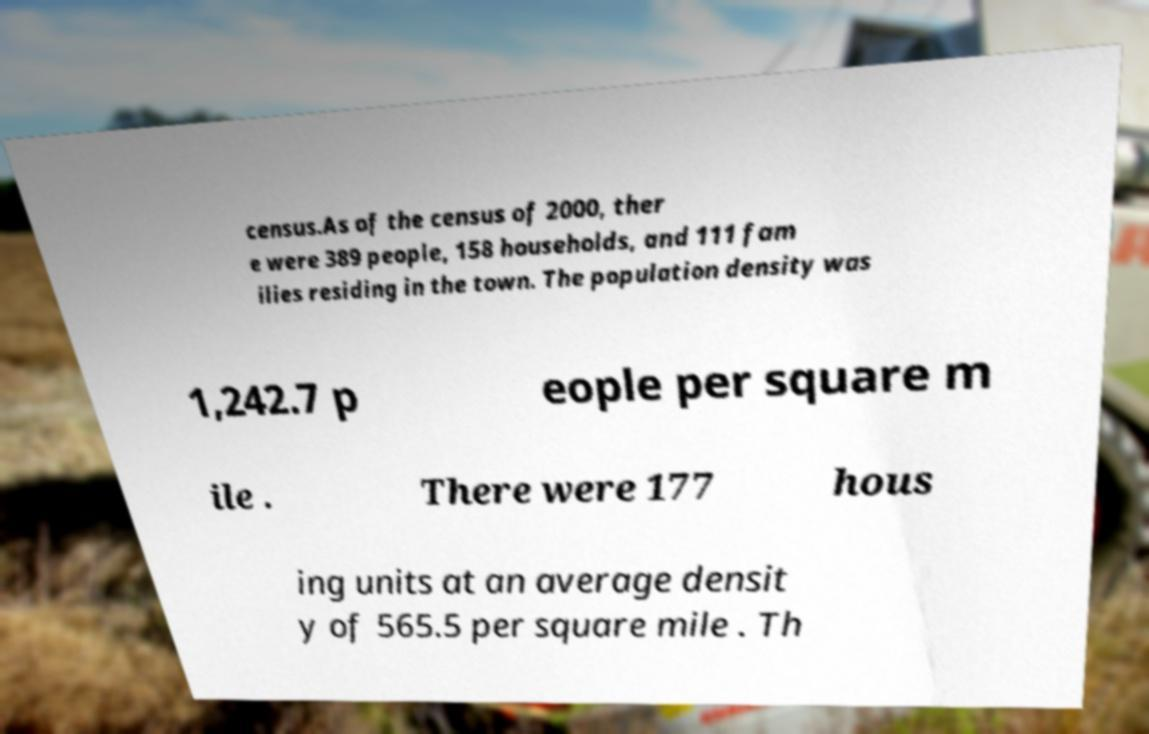What messages or text are displayed in this image? I need them in a readable, typed format. census.As of the census of 2000, ther e were 389 people, 158 households, and 111 fam ilies residing in the town. The population density was 1,242.7 p eople per square m ile . There were 177 hous ing units at an average densit y of 565.5 per square mile . Th 